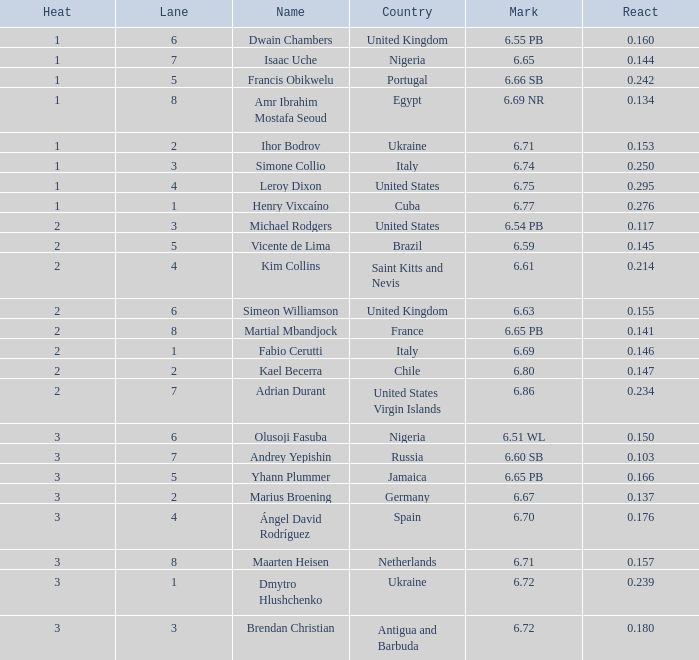What is the lowest Lane, when Country is France, and when React is less than 0.14100000000000001? 8.0. 